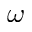<formula> <loc_0><loc_0><loc_500><loc_500>\omega</formula> 